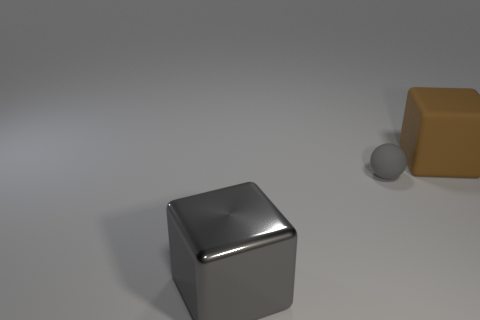What materials do the objects in the image appear to be made of? The cube in the foreground has a reflective surface suggesting a material like metal or polished plastic. The brown block looks like it might be made of wood or a wood-like material, and the small sphere appears to have a matte finish, possibly indicative of a stone or ceramic material. 